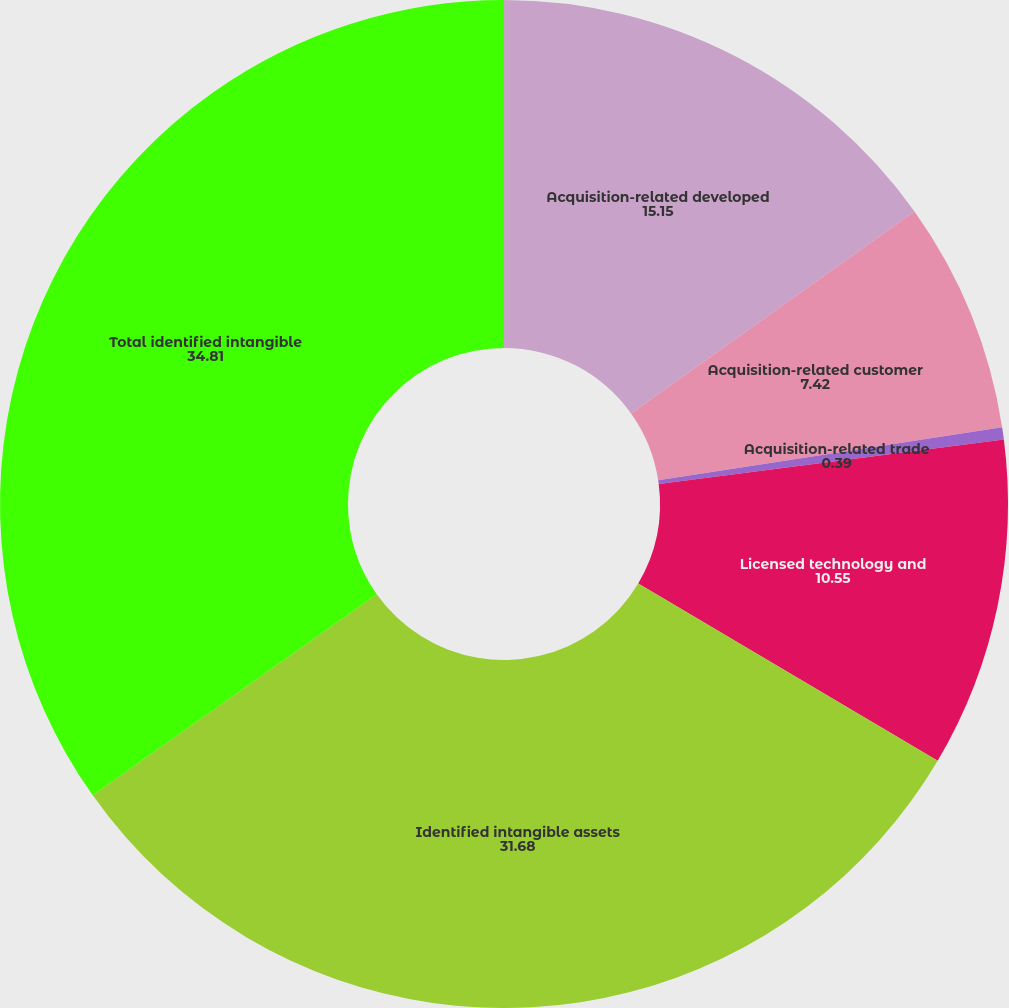Convert chart to OTSL. <chart><loc_0><loc_0><loc_500><loc_500><pie_chart><fcel>Acquisition-related developed<fcel>Acquisition-related customer<fcel>Acquisition-related trade<fcel>Licensed technology and<fcel>Identified intangible assets<fcel>Total identified intangible<nl><fcel>15.15%<fcel>7.42%<fcel>0.39%<fcel>10.55%<fcel>31.68%<fcel>34.81%<nl></chart> 